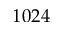Convert formula to latex. <formula><loc_0><loc_0><loc_500><loc_500>1 0 2 4</formula> 